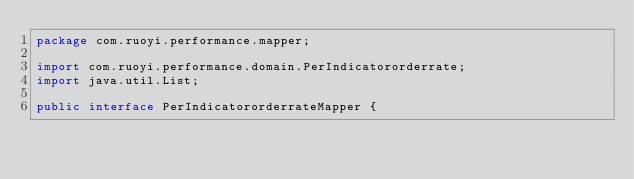Convert code to text. <code><loc_0><loc_0><loc_500><loc_500><_Java_>package com.ruoyi.performance.mapper;

import com.ruoyi.performance.domain.PerIndicatororderrate;
import java.util.List;

public interface PerIndicatororderrateMapper {
</code> 